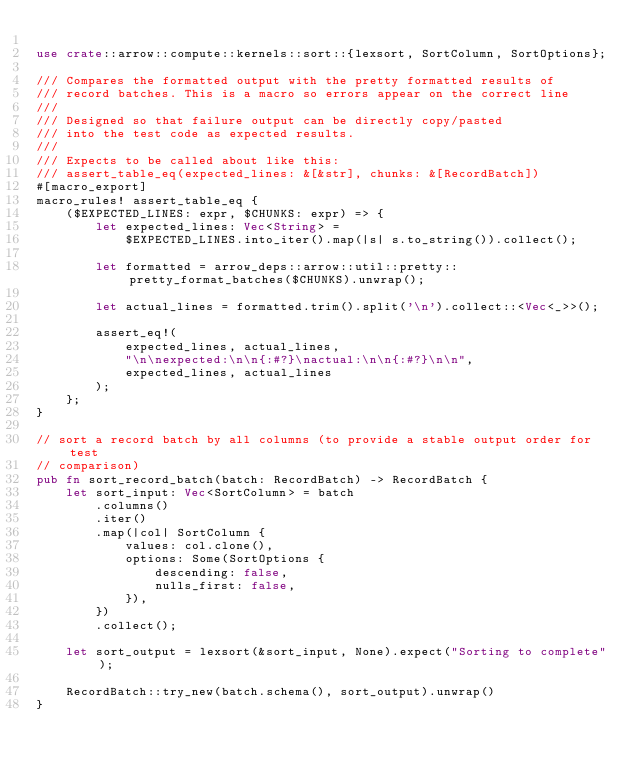<code> <loc_0><loc_0><loc_500><loc_500><_Rust_>
use crate::arrow::compute::kernels::sort::{lexsort, SortColumn, SortOptions};

/// Compares the formatted output with the pretty formatted results of
/// record batches. This is a macro so errors appear on the correct line
///
/// Designed so that failure output can be directly copy/pasted
/// into the test code as expected results.
///
/// Expects to be called about like this:
/// assert_table_eq(expected_lines: &[&str], chunks: &[RecordBatch])
#[macro_export]
macro_rules! assert_table_eq {
    ($EXPECTED_LINES: expr, $CHUNKS: expr) => {
        let expected_lines: Vec<String> =
            $EXPECTED_LINES.into_iter().map(|s| s.to_string()).collect();

        let formatted = arrow_deps::arrow::util::pretty::pretty_format_batches($CHUNKS).unwrap();

        let actual_lines = formatted.trim().split('\n').collect::<Vec<_>>();

        assert_eq!(
            expected_lines, actual_lines,
            "\n\nexpected:\n\n{:#?}\nactual:\n\n{:#?}\n\n",
            expected_lines, actual_lines
        );
    };
}

// sort a record batch by all columns (to provide a stable output order for test
// comparison)
pub fn sort_record_batch(batch: RecordBatch) -> RecordBatch {
    let sort_input: Vec<SortColumn> = batch
        .columns()
        .iter()
        .map(|col| SortColumn {
            values: col.clone(),
            options: Some(SortOptions {
                descending: false,
                nulls_first: false,
            }),
        })
        .collect();

    let sort_output = lexsort(&sort_input, None).expect("Sorting to complete");

    RecordBatch::try_new(batch.schema(), sort_output).unwrap()
}
</code> 